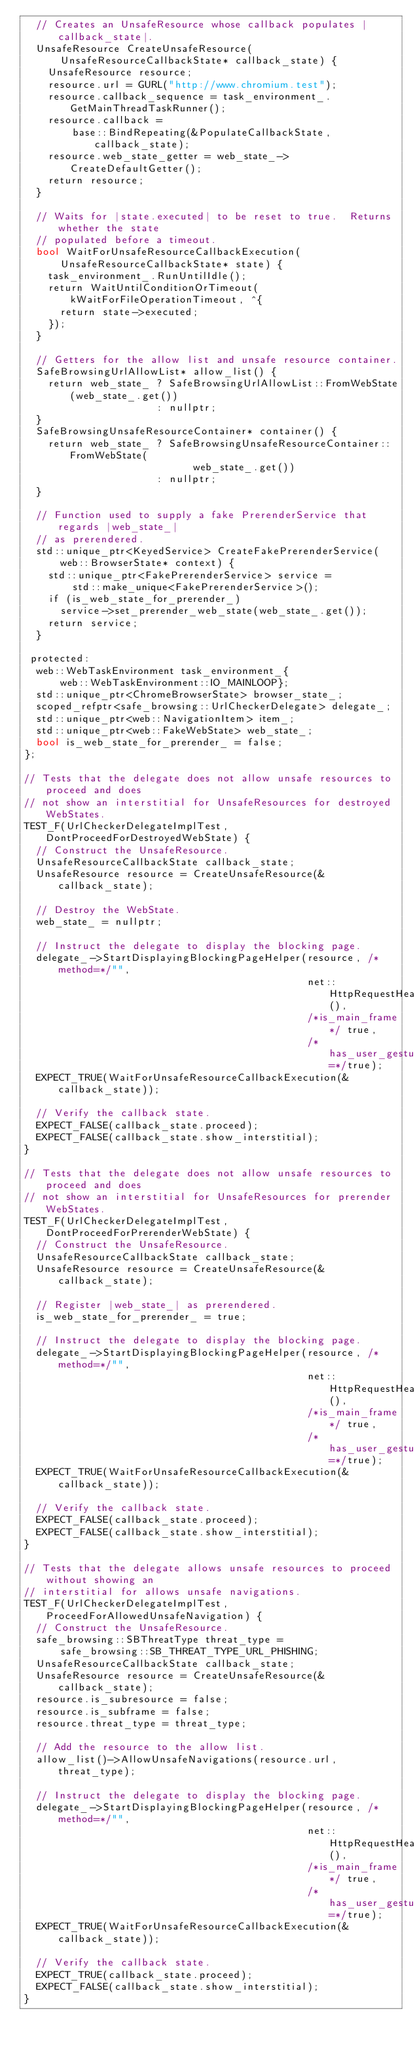Convert code to text. <code><loc_0><loc_0><loc_500><loc_500><_ObjectiveC_>  // Creates an UnsafeResource whose callback populates |callback_state|.
  UnsafeResource CreateUnsafeResource(
      UnsafeResourceCallbackState* callback_state) {
    UnsafeResource resource;
    resource.url = GURL("http://www.chromium.test");
    resource.callback_sequence = task_environment_.GetMainThreadTaskRunner();
    resource.callback =
        base::BindRepeating(&PopulateCallbackState, callback_state);
    resource.web_state_getter = web_state_->CreateDefaultGetter();
    return resource;
  }

  // Waits for |state.executed| to be reset to true.  Returns whether the state
  // populated before a timeout.
  bool WaitForUnsafeResourceCallbackExecution(
      UnsafeResourceCallbackState* state) {
    task_environment_.RunUntilIdle();
    return WaitUntilConditionOrTimeout(kWaitForFileOperationTimeout, ^{
      return state->executed;
    });
  }

  // Getters for the allow list and unsafe resource container.
  SafeBrowsingUrlAllowList* allow_list() {
    return web_state_ ? SafeBrowsingUrlAllowList::FromWebState(web_state_.get())
                      : nullptr;
  }
  SafeBrowsingUnsafeResourceContainer* container() {
    return web_state_ ? SafeBrowsingUnsafeResourceContainer::FromWebState(
                            web_state_.get())
                      : nullptr;
  }

  // Function used to supply a fake PrerenderService that regards |web_state_|
  // as prerendered.
  std::unique_ptr<KeyedService> CreateFakePrerenderService(
      web::BrowserState* context) {
    std::unique_ptr<FakePrerenderService> service =
        std::make_unique<FakePrerenderService>();
    if (is_web_state_for_prerender_)
      service->set_prerender_web_state(web_state_.get());
    return service;
  }

 protected:
  web::WebTaskEnvironment task_environment_{
      web::WebTaskEnvironment::IO_MAINLOOP};
  std::unique_ptr<ChromeBrowserState> browser_state_;
  scoped_refptr<safe_browsing::UrlCheckerDelegate> delegate_;
  std::unique_ptr<web::NavigationItem> item_;
  std::unique_ptr<web::FakeWebState> web_state_;
  bool is_web_state_for_prerender_ = false;
};

// Tests that the delegate does not allow unsafe resources to proceed and does
// not show an interstitial for UnsafeResources for destroyed WebStates.
TEST_F(UrlCheckerDelegateImplTest, DontProceedForDestroyedWebState) {
  // Construct the UnsafeResource.
  UnsafeResourceCallbackState callback_state;
  UnsafeResource resource = CreateUnsafeResource(&callback_state);

  // Destroy the WebState.
  web_state_ = nullptr;

  // Instruct the delegate to display the blocking page.
  delegate_->StartDisplayingBlockingPageHelper(resource, /*method=*/"",
                                               net::HttpRequestHeaders(),
                                               /*is_main_frame*/ true,
                                               /*has_user_gesture=*/true);
  EXPECT_TRUE(WaitForUnsafeResourceCallbackExecution(&callback_state));

  // Verify the callback state.
  EXPECT_FALSE(callback_state.proceed);
  EXPECT_FALSE(callback_state.show_interstitial);
}

// Tests that the delegate does not allow unsafe resources to proceed and does
// not show an interstitial for UnsafeResources for prerender WebStates.
TEST_F(UrlCheckerDelegateImplTest, DontProceedForPrerenderWebState) {
  // Construct the UnsafeResource.
  UnsafeResourceCallbackState callback_state;
  UnsafeResource resource = CreateUnsafeResource(&callback_state);

  // Register |web_state_| as prerendered.
  is_web_state_for_prerender_ = true;

  // Instruct the delegate to display the blocking page.
  delegate_->StartDisplayingBlockingPageHelper(resource, /*method=*/"",
                                               net::HttpRequestHeaders(),
                                               /*is_main_frame*/ true,
                                               /*has_user_gesture=*/true);
  EXPECT_TRUE(WaitForUnsafeResourceCallbackExecution(&callback_state));

  // Verify the callback state.
  EXPECT_FALSE(callback_state.proceed);
  EXPECT_FALSE(callback_state.show_interstitial);
}

// Tests that the delegate allows unsafe resources to proceed without showing an
// interstitial for allows unsafe navigations.
TEST_F(UrlCheckerDelegateImplTest, ProceedForAllowedUnsafeNavigation) {
  // Construct the UnsafeResource.
  safe_browsing::SBThreatType threat_type =
      safe_browsing::SB_THREAT_TYPE_URL_PHISHING;
  UnsafeResourceCallbackState callback_state;
  UnsafeResource resource = CreateUnsafeResource(&callback_state);
  resource.is_subresource = false;
  resource.is_subframe = false;
  resource.threat_type = threat_type;

  // Add the resource to the allow list.
  allow_list()->AllowUnsafeNavigations(resource.url, threat_type);

  // Instruct the delegate to display the blocking page.
  delegate_->StartDisplayingBlockingPageHelper(resource, /*method=*/"",
                                               net::HttpRequestHeaders(),
                                               /*is_main_frame*/ true,
                                               /*has_user_gesture=*/true);
  EXPECT_TRUE(WaitForUnsafeResourceCallbackExecution(&callback_state));

  // Verify the callback state.
  EXPECT_TRUE(callback_state.proceed);
  EXPECT_FALSE(callback_state.show_interstitial);
}
</code> 